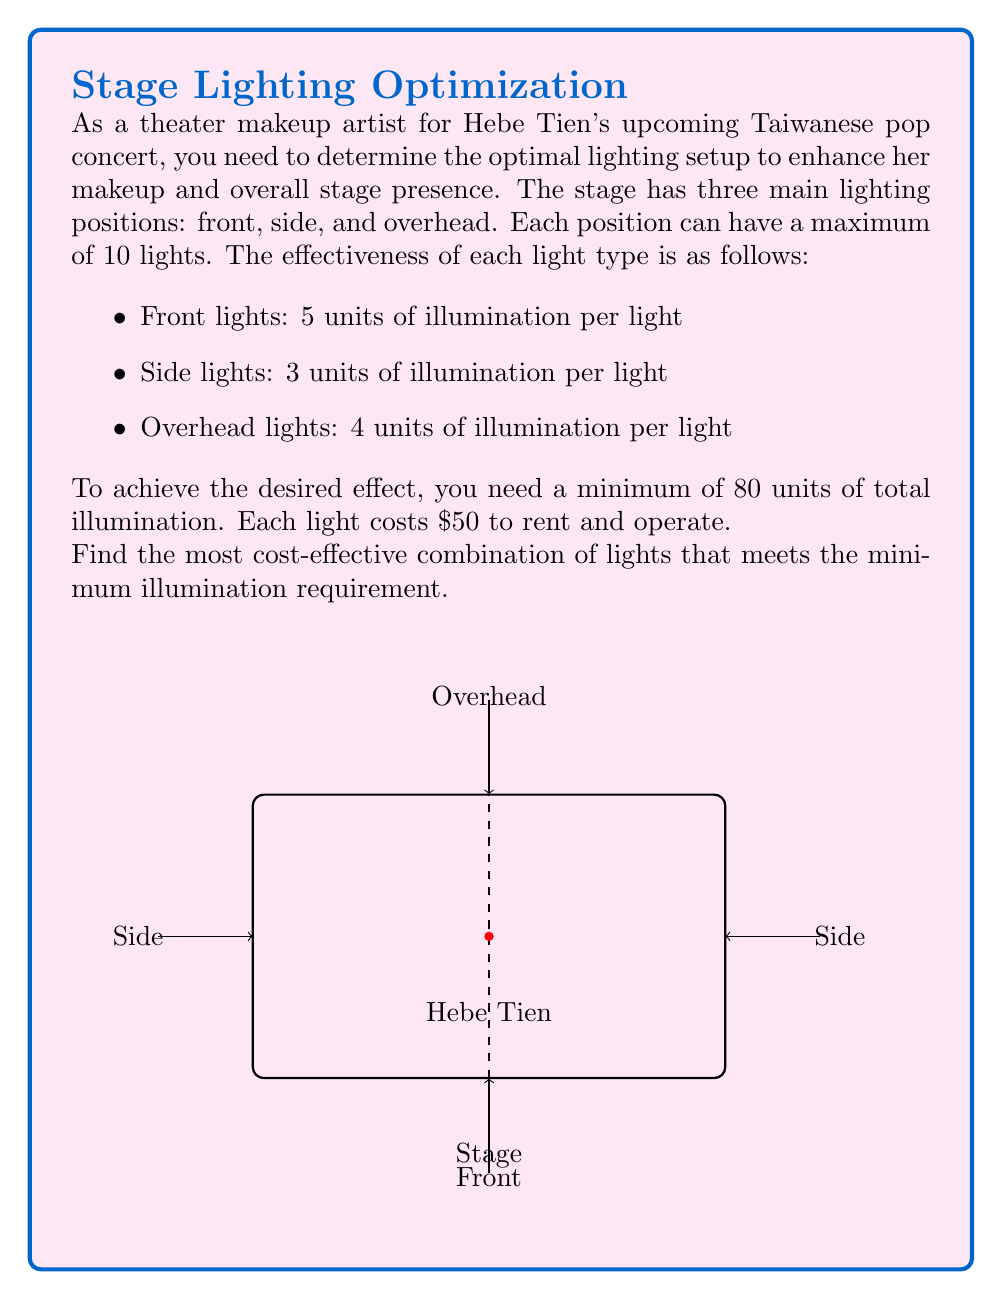Can you solve this math problem? Let's approach this optimization problem step-by-step using linear programming:

1) Define variables:
   Let $x$ = number of front lights
       $y$ = number of side lights
       $z$ = number of overhead lights

2) Objective function (to minimize cost):
   $\text{Cost} = 50x + 50y + 50z$

3) Constraints:
   a) Illumination requirement: $5x + 3y + 4z \geq 80$
   b) Maximum lights per position: $x \leq 10$, $y \leq 10$, $z \leq 10$
   c) Non-negativity: $x, y, z \geq 0$ and integers

4) We can solve this using the simplex method or integer programming. However, given the small scale, we can also use a systematic approach:

   - We need at least 80 units of illumination.
   - Front lights are most effective (5 units each).
   - We can start with front lights and add others as needed.

5) Try combinations:
   - 16 front lights would suffice, but exceeds the maximum of 10.
   - 10 front lights = 50 units, need 30 more.
   - 7 overhead lights = 28 units, still need 2 more.
   - 1 side light = 3 units, which exceeds the requirement.

6) Therefore, the optimal solution is:
   10 front lights and 8 overhead lights
   Total illumination: $10 * 5 + 8 * 4 = 82$ units
   Total cost: $50 * (10 + 8) = $900$

This solution meets the illumination requirement and uses the fewest lights possible, minimizing the cost.
Answer: 10 front lights, 8 overhead lights; Cost: $900 